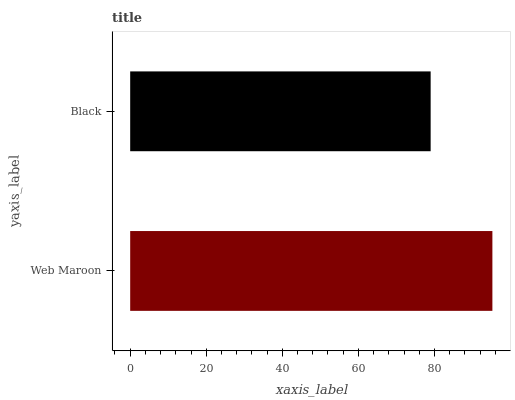Is Black the minimum?
Answer yes or no. Yes. Is Web Maroon the maximum?
Answer yes or no. Yes. Is Black the maximum?
Answer yes or no. No. Is Web Maroon greater than Black?
Answer yes or no. Yes. Is Black less than Web Maroon?
Answer yes or no. Yes. Is Black greater than Web Maroon?
Answer yes or no. No. Is Web Maroon less than Black?
Answer yes or no. No. Is Web Maroon the high median?
Answer yes or no. Yes. Is Black the low median?
Answer yes or no. Yes. Is Black the high median?
Answer yes or no. No. Is Web Maroon the low median?
Answer yes or no. No. 